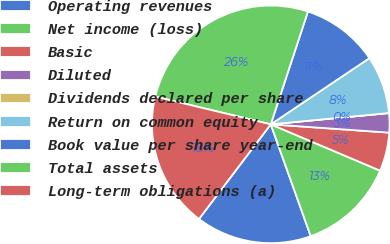<chart> <loc_0><loc_0><loc_500><loc_500><pie_chart><fcel>Operating revenues<fcel>Net income (loss)<fcel>Basic<fcel>Diluted<fcel>Dividends declared per share<fcel>Return on common equity<fcel>Book value per share year-end<fcel>Total assets<fcel>Long-term obligations (a)<nl><fcel>15.79%<fcel>13.16%<fcel>5.26%<fcel>2.63%<fcel>0.0%<fcel>7.89%<fcel>10.53%<fcel>26.32%<fcel>18.42%<nl></chart> 